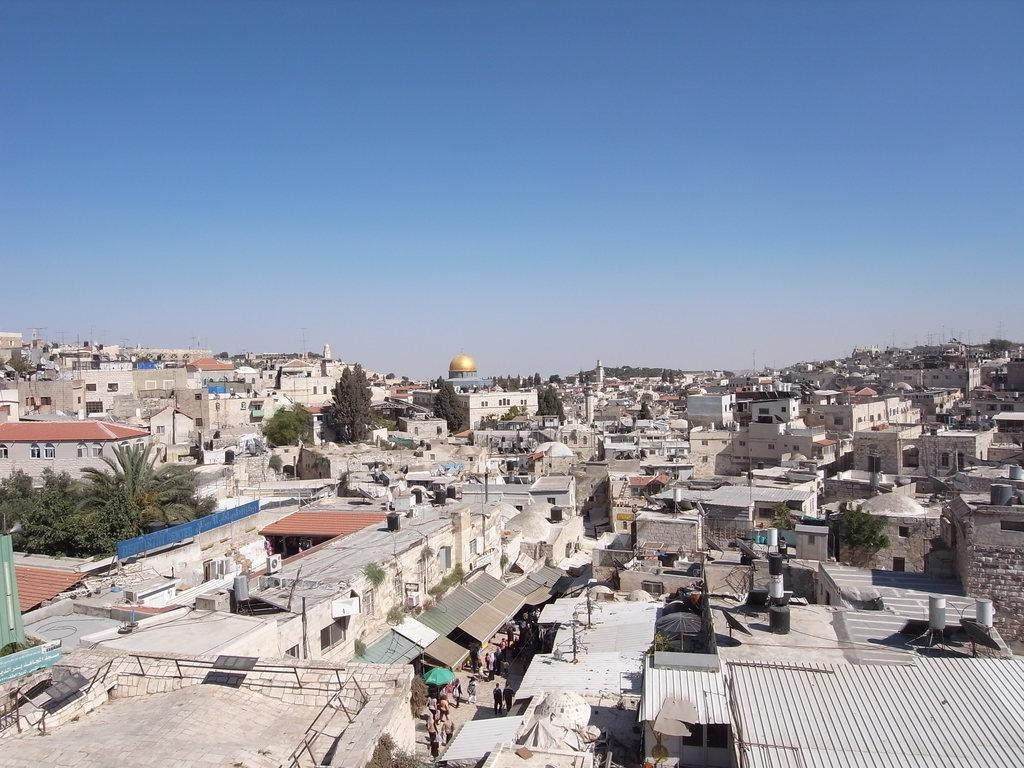What type of structures can be seen in the image? There are many houses in the image. What else can be seen in the image besides houses? There are trees and people walking on the road in the image. What is the color of the dome visible in the image? The dome in the image is gold-colored. What is visible at the top of the image? The sky is visible at the top of the image. Where is the crate of beans located in the image? There is no crate of beans present in the image. Is the volcano erupting in the image? There is no volcano present in the image. 